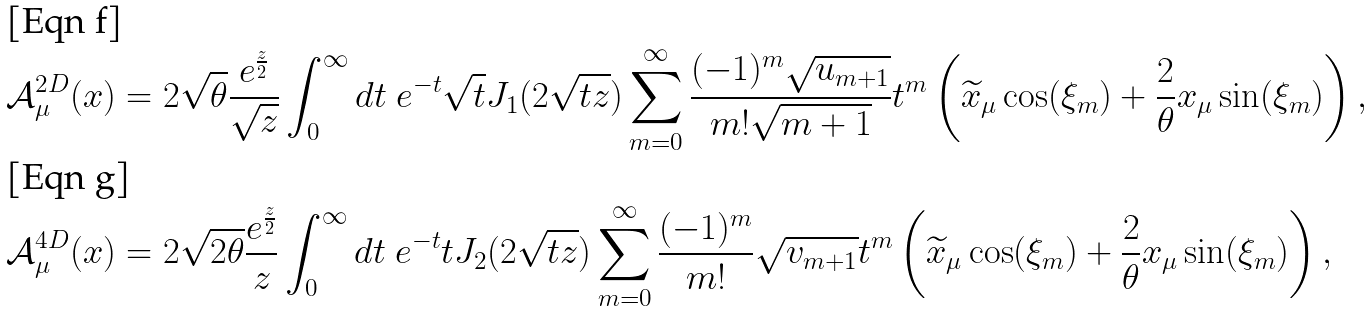Convert formula to latex. <formula><loc_0><loc_0><loc_500><loc_500>\mathcal { A } _ { \mu } ^ { 2 D } ( x ) & = 2 \sqrt { \theta } \frac { e ^ { \frac { z } { 2 } } } { \sqrt { z } } \int _ { 0 } ^ { \infty } d t \ e ^ { - t } \sqrt { t } J _ { 1 } ( 2 \sqrt { t z } ) \sum _ { m = 0 } ^ { \infty } \frac { ( - 1 ) ^ { m } \sqrt { u _ { m + 1 } } } { m ! \sqrt { m + 1 } } t ^ { m } \left ( \widetilde { x } _ { \mu } \cos ( \xi _ { m } ) + \frac { 2 } { \theta } x _ { \mu } \sin ( \xi _ { m } ) \right ) , \\ \mathcal { A } _ { \mu } ^ { 4 D } ( x ) & = 2 \sqrt { 2 \theta } \frac { e ^ { \frac { z } { 2 } } } { z } \int _ { 0 } ^ { \infty } d t \ e ^ { - t } t J _ { 2 } ( 2 \sqrt { t z } ) \sum _ { m = 0 } ^ { \infty } \frac { ( - 1 ) ^ { m } } { m ! } \sqrt { v _ { m + 1 } } t ^ { m } \left ( \widetilde { x } _ { \mu } \cos ( \xi _ { m } ) + \frac { 2 } { \theta } x _ { \mu } \sin ( \xi _ { m } ) \right ) ,</formula> 